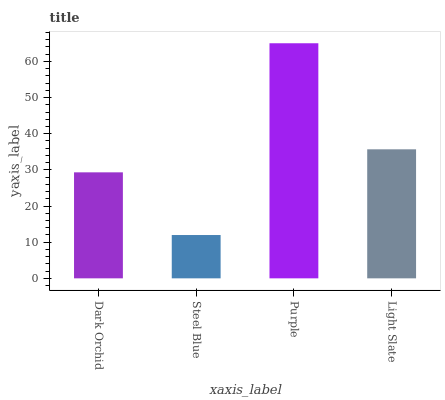Is Steel Blue the minimum?
Answer yes or no. Yes. Is Purple the maximum?
Answer yes or no. Yes. Is Purple the minimum?
Answer yes or no. No. Is Steel Blue the maximum?
Answer yes or no. No. Is Purple greater than Steel Blue?
Answer yes or no. Yes. Is Steel Blue less than Purple?
Answer yes or no. Yes. Is Steel Blue greater than Purple?
Answer yes or no. No. Is Purple less than Steel Blue?
Answer yes or no. No. Is Light Slate the high median?
Answer yes or no. Yes. Is Dark Orchid the low median?
Answer yes or no. Yes. Is Dark Orchid the high median?
Answer yes or no. No. Is Purple the low median?
Answer yes or no. No. 